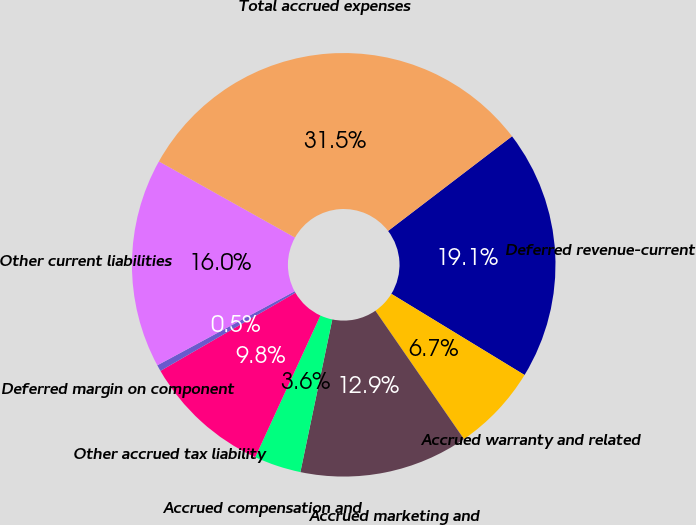Convert chart to OTSL. <chart><loc_0><loc_0><loc_500><loc_500><pie_chart><fcel>Deferred revenue-current<fcel>Accrued warranty and related<fcel>Accrued marketing and<fcel>Accrued compensation and<fcel>Other accrued tax liability<fcel>Deferred margin on component<fcel>Other current liabilities<fcel>Total accrued expenses<nl><fcel>19.09%<fcel>6.68%<fcel>12.89%<fcel>3.58%<fcel>9.79%<fcel>0.48%<fcel>15.99%<fcel>31.5%<nl></chart> 